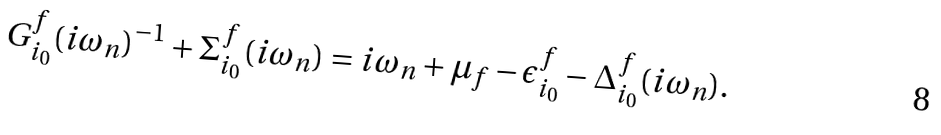Convert formula to latex. <formula><loc_0><loc_0><loc_500><loc_500>G _ { i _ { 0 } } ^ { f } ( i \omega _ { n } ) ^ { - 1 } + \Sigma _ { i _ { 0 } } ^ { f } ( i \omega _ { n } ) = i \omega _ { n } + \mu _ { f } - \epsilon _ { i _ { 0 } } ^ { f } - \Delta _ { i _ { 0 } } ^ { f } ( i \omega _ { n } ) .</formula> 